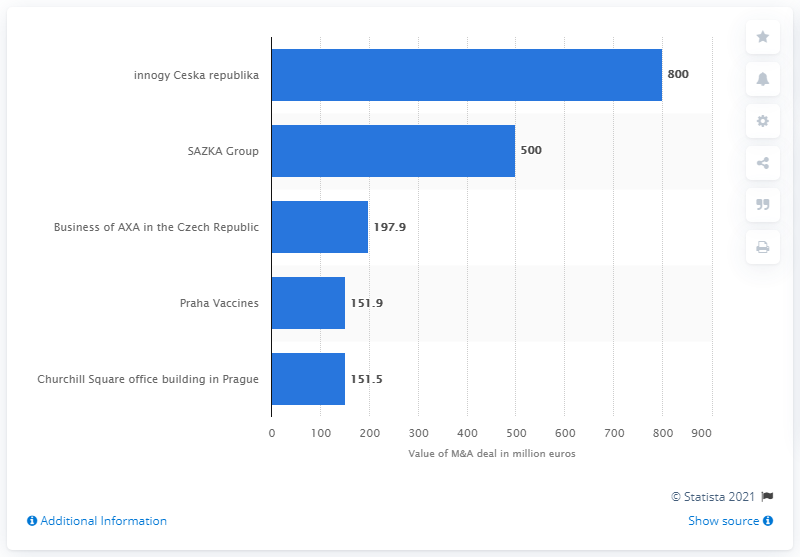Identify some key points in this picture. The smallest deal in the top five amounted to 197.9... MVM has acquired a 100% stake in innogy Ceska republika for 800... The second largest M&A deal cost 500. 